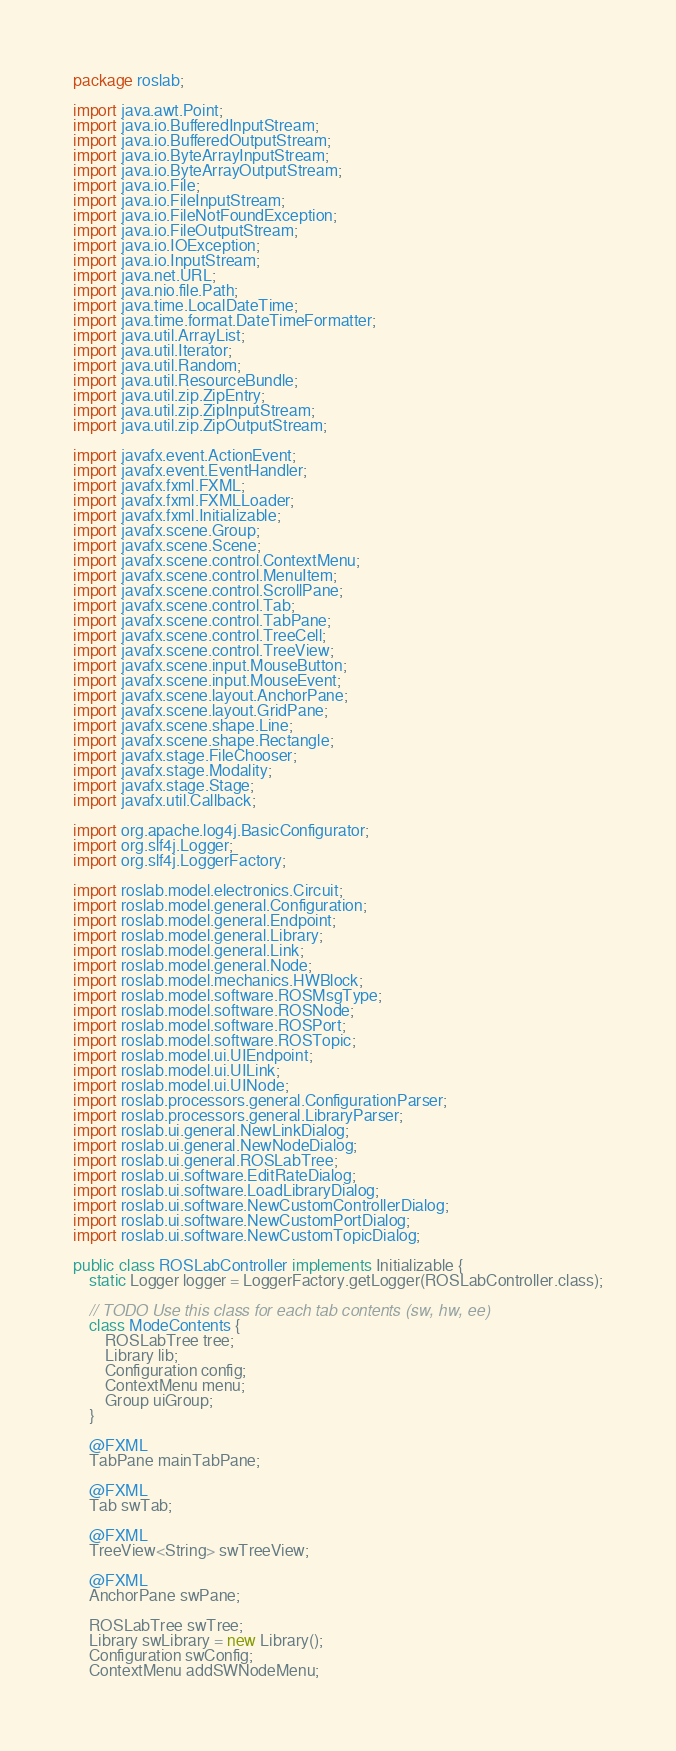<code> <loc_0><loc_0><loc_500><loc_500><_Java_>package roslab;

import java.awt.Point;
import java.io.BufferedInputStream;
import java.io.BufferedOutputStream;
import java.io.ByteArrayInputStream;
import java.io.ByteArrayOutputStream;
import java.io.File;
import java.io.FileInputStream;
import java.io.FileNotFoundException;
import java.io.FileOutputStream;
import java.io.IOException;
import java.io.InputStream;
import java.net.URL;
import java.nio.file.Path;
import java.time.LocalDateTime;
import java.time.format.DateTimeFormatter;
import java.util.ArrayList;
import java.util.Iterator;
import java.util.Random;
import java.util.ResourceBundle;
import java.util.zip.ZipEntry;
import java.util.zip.ZipInputStream;
import java.util.zip.ZipOutputStream;

import javafx.event.ActionEvent;
import javafx.event.EventHandler;
import javafx.fxml.FXML;
import javafx.fxml.FXMLLoader;
import javafx.fxml.Initializable;
import javafx.scene.Group;
import javafx.scene.Scene;
import javafx.scene.control.ContextMenu;
import javafx.scene.control.MenuItem;
import javafx.scene.control.ScrollPane;
import javafx.scene.control.Tab;
import javafx.scene.control.TabPane;
import javafx.scene.control.TreeCell;
import javafx.scene.control.TreeView;
import javafx.scene.input.MouseButton;
import javafx.scene.input.MouseEvent;
import javafx.scene.layout.AnchorPane;
import javafx.scene.layout.GridPane;
import javafx.scene.shape.Line;
import javafx.scene.shape.Rectangle;
import javafx.stage.FileChooser;
import javafx.stage.Modality;
import javafx.stage.Stage;
import javafx.util.Callback;

import org.apache.log4j.BasicConfigurator;
import org.slf4j.Logger;
import org.slf4j.LoggerFactory;

import roslab.model.electronics.Circuit;
import roslab.model.general.Configuration;
import roslab.model.general.Endpoint;
import roslab.model.general.Library;
import roslab.model.general.Link;
import roslab.model.general.Node;
import roslab.model.mechanics.HWBlock;
import roslab.model.software.ROSMsgType;
import roslab.model.software.ROSNode;
import roslab.model.software.ROSPort;
import roslab.model.software.ROSTopic;
import roslab.model.ui.UIEndpoint;
import roslab.model.ui.UILink;
import roslab.model.ui.UINode;
import roslab.processors.general.ConfigurationParser;
import roslab.processors.general.LibraryParser;
import roslab.ui.general.NewLinkDialog;
import roslab.ui.general.NewNodeDialog;
import roslab.ui.general.ROSLabTree;
import roslab.ui.software.EditRateDialog;
import roslab.ui.software.LoadLibraryDialog;
import roslab.ui.software.NewCustomControllerDialog;
import roslab.ui.software.NewCustomPortDialog;
import roslab.ui.software.NewCustomTopicDialog;

public class ROSLabController implements Initializable {
    static Logger logger = LoggerFactory.getLogger(ROSLabController.class);

    // TODO Use this class for each tab contents (sw, hw, ee)
    class ModeContents {
        ROSLabTree tree;
        Library lib;
        Configuration config;
        ContextMenu menu;
        Group uiGroup;
    }

    @FXML
    TabPane mainTabPane;

    @FXML
    Tab swTab;

    @FXML
    TreeView<String> swTreeView;

    @FXML
    AnchorPane swPane;

    ROSLabTree swTree;
    Library swLibrary = new Library();
    Configuration swConfig;
    ContextMenu addSWNodeMenu;</code> 